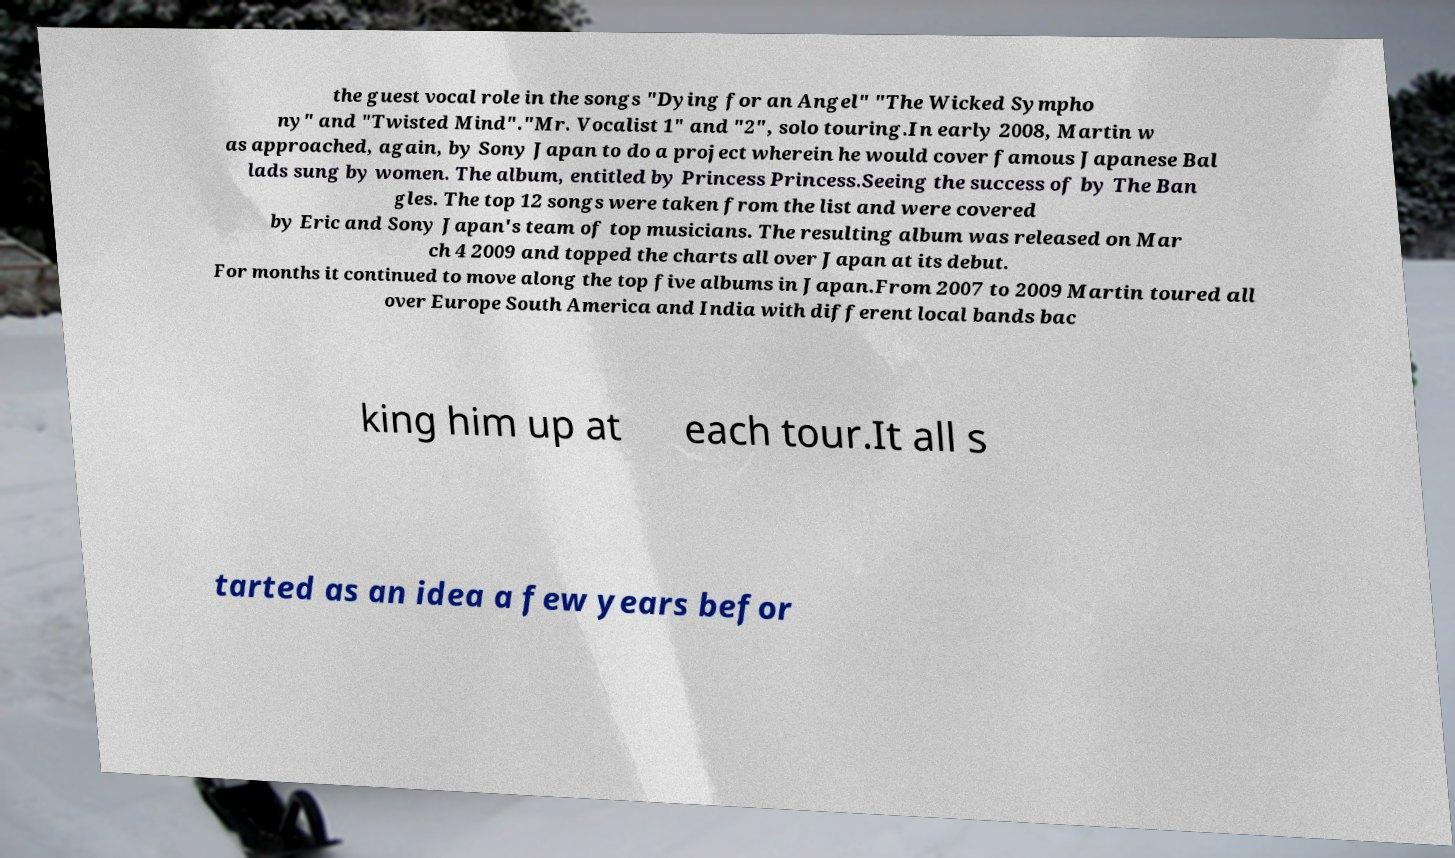Please identify and transcribe the text found in this image. the guest vocal role in the songs "Dying for an Angel" "The Wicked Sympho ny" and "Twisted Mind"."Mr. Vocalist 1" and "2", solo touring.In early 2008, Martin w as approached, again, by Sony Japan to do a project wherein he would cover famous Japanese Bal lads sung by women. The album, entitled by Princess Princess.Seeing the success of by The Ban gles. The top 12 songs were taken from the list and were covered by Eric and Sony Japan's team of top musicians. The resulting album was released on Mar ch 4 2009 and topped the charts all over Japan at its debut. For months it continued to move along the top five albums in Japan.From 2007 to 2009 Martin toured all over Europe South America and India with different local bands bac king him up at each tour.It all s tarted as an idea a few years befor 